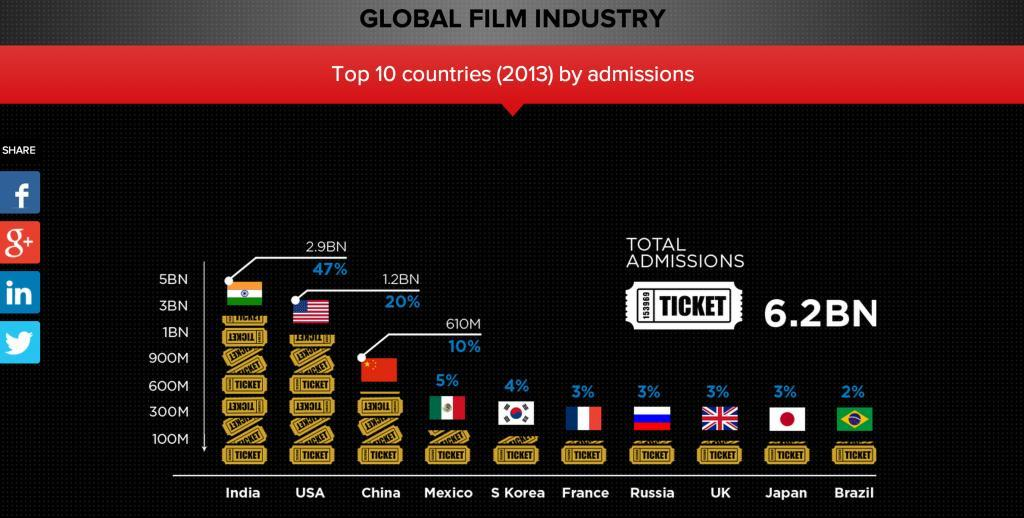How many tickets were sold in India and USA combined?
Answer the question with a short phrase. 4.1BN Which country sold more number of tickets than USA and China put together? India Which country contributed 4% of total movie admissions? S Korea How many countries show 3% admissions? 4 What was the total number of ticket admissions in China in 2013? 610M Which country sold the second highest number of movie tickets in 2013? USA What percentage of total movie admissions in 2013 was from India? 47% Which country made a sale of tickets nearly equal to half of the tickets sold in USA? China 1.2 billion ticket admissions in 2013 was from which country? USA What was the total number of movie admissions worldwide in 2013? 6.2BN 